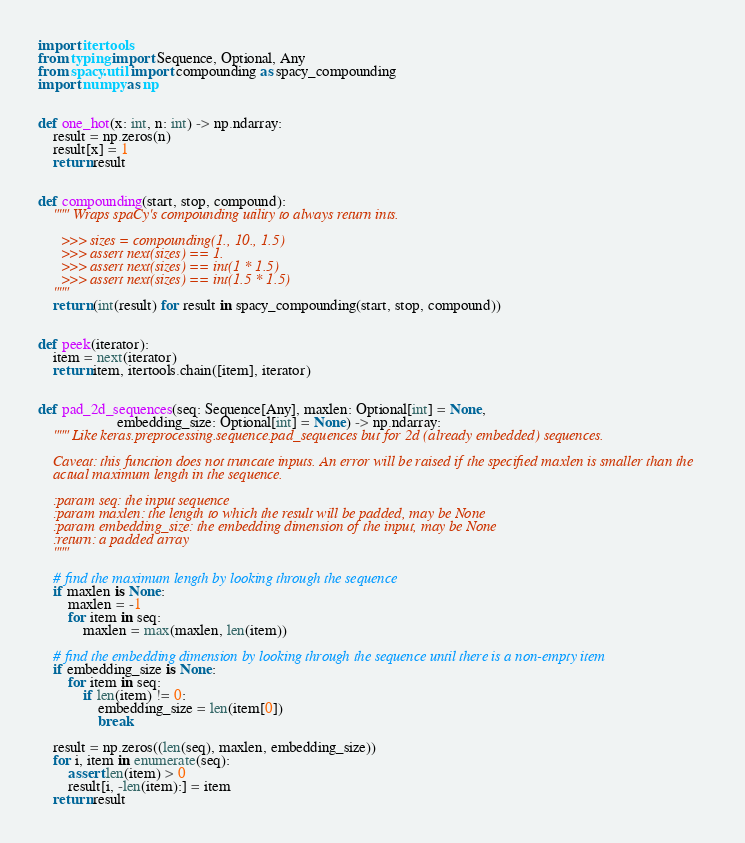Convert code to text. <code><loc_0><loc_0><loc_500><loc_500><_Python_>import itertools
from typing import Sequence, Optional, Any
from spacy.util import compounding as spacy_compounding
import numpy as np


def one_hot(x: int, n: int) -> np.ndarray:
    result = np.zeros(n)
    result[x] = 1
    return result


def compounding(start, stop, compound):
    """ Wraps spaCy's compounding utility to always return ints.

      >>> sizes = compounding(1., 10., 1.5)
      >>> assert next(sizes) == 1.
      >>> assert next(sizes) == int(1 * 1.5)
      >>> assert next(sizes) == int(1.5 * 1.5)
    """
    return (int(result) for result in spacy_compounding(start, stop, compound))


def peek(iterator):
    item = next(iterator)
    return item, itertools.chain([item], iterator)


def pad_2d_sequences(seq: Sequence[Any], maxlen: Optional[int] = None,
                     embedding_size: Optional[int] = None) -> np.ndarray:
    """ Like keras.preprocessing.sequence.pad_sequences but for 2d (already embedded) sequences.

    Caveat: this function does not truncate inputs. An error will be raised if the specified maxlen is smaller than the
    actual maximum length in the sequence.

    :param seq: the input sequence
    :param maxlen: the length to which the result will be padded, may be None
    :param embedding_size: the embedding dimension of the input, may be None
    :return: a padded array
    """

    # find the maximum length by looking through the sequence
    if maxlen is None:
        maxlen = -1
        for item in seq:
            maxlen = max(maxlen, len(item))

    # find the embedding dimension by looking through the sequence until there is a non-empty item
    if embedding_size is None:
        for item in seq:
            if len(item) != 0:
                embedding_size = len(item[0])
                break

    result = np.zeros((len(seq), maxlen, embedding_size))
    for i, item in enumerate(seq):
        assert len(item) > 0
        result[i, -len(item):] = item
    return result
</code> 